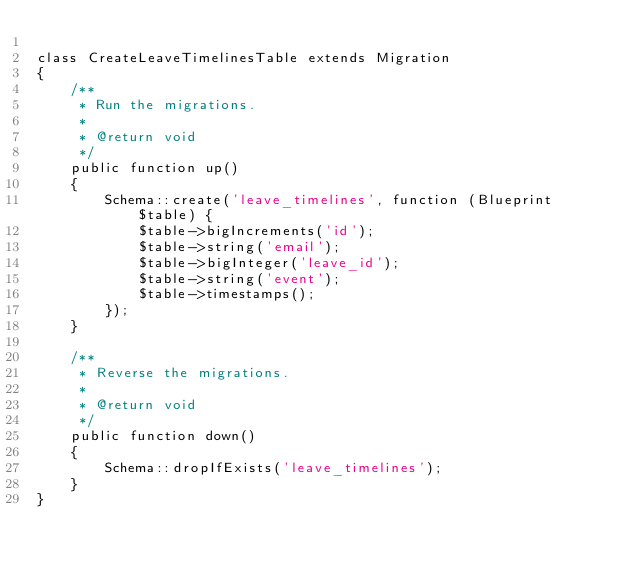Convert code to text. <code><loc_0><loc_0><loc_500><loc_500><_PHP_>
class CreateLeaveTimelinesTable extends Migration
{
    /**
     * Run the migrations.
     *
     * @return void
     */
    public function up()
    {
        Schema::create('leave_timelines', function (Blueprint $table) {
            $table->bigIncrements('id');
            $table->string('email');
            $table->bigInteger('leave_id');
            $table->string('event');
            $table->timestamps();
        });
    }

    /**
     * Reverse the migrations.
     *
     * @return void
     */
    public function down()
    {
        Schema::dropIfExists('leave_timelines');
    }
}
</code> 